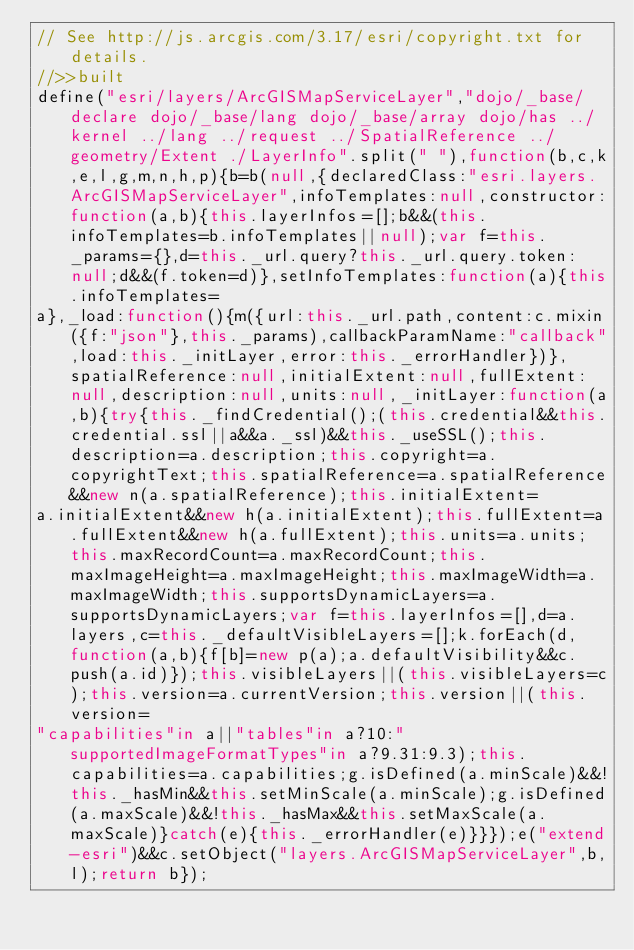<code> <loc_0><loc_0><loc_500><loc_500><_JavaScript_>// See http://js.arcgis.com/3.17/esri/copyright.txt for details.
//>>built
define("esri/layers/ArcGISMapServiceLayer","dojo/_base/declare dojo/_base/lang dojo/_base/array dojo/has ../kernel ../lang ../request ../SpatialReference ../geometry/Extent ./LayerInfo".split(" "),function(b,c,k,e,l,g,m,n,h,p){b=b(null,{declaredClass:"esri.layers.ArcGISMapServiceLayer",infoTemplates:null,constructor:function(a,b){this.layerInfos=[];b&&(this.infoTemplates=b.infoTemplates||null);var f=this._params={},d=this._url.query?this._url.query.token:null;d&&(f.token=d)},setInfoTemplates:function(a){this.infoTemplates=
a},_load:function(){m({url:this._url.path,content:c.mixin({f:"json"},this._params),callbackParamName:"callback",load:this._initLayer,error:this._errorHandler})},spatialReference:null,initialExtent:null,fullExtent:null,description:null,units:null,_initLayer:function(a,b){try{this._findCredential();(this.credential&&this.credential.ssl||a&&a._ssl)&&this._useSSL();this.description=a.description;this.copyright=a.copyrightText;this.spatialReference=a.spatialReference&&new n(a.spatialReference);this.initialExtent=
a.initialExtent&&new h(a.initialExtent);this.fullExtent=a.fullExtent&&new h(a.fullExtent);this.units=a.units;this.maxRecordCount=a.maxRecordCount;this.maxImageHeight=a.maxImageHeight;this.maxImageWidth=a.maxImageWidth;this.supportsDynamicLayers=a.supportsDynamicLayers;var f=this.layerInfos=[],d=a.layers,c=this._defaultVisibleLayers=[];k.forEach(d,function(a,b){f[b]=new p(a);a.defaultVisibility&&c.push(a.id)});this.visibleLayers||(this.visibleLayers=c);this.version=a.currentVersion;this.version||(this.version=
"capabilities"in a||"tables"in a?10:"supportedImageFormatTypes"in a?9.31:9.3);this.capabilities=a.capabilities;g.isDefined(a.minScale)&&!this._hasMin&&this.setMinScale(a.minScale);g.isDefined(a.maxScale)&&!this._hasMax&&this.setMaxScale(a.maxScale)}catch(e){this._errorHandler(e)}}});e("extend-esri")&&c.setObject("layers.ArcGISMapServiceLayer",b,l);return b});</code> 